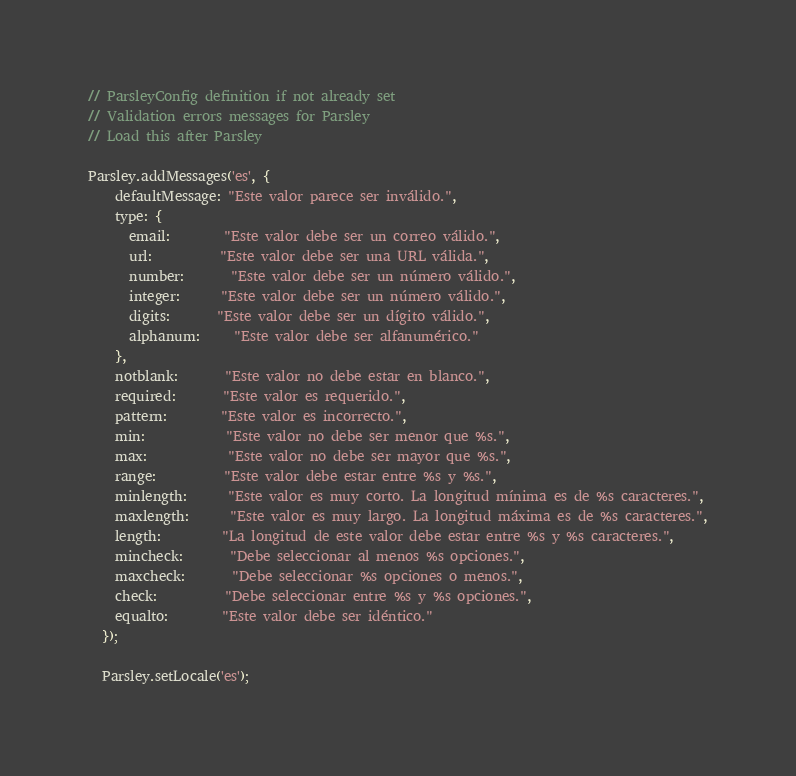Convert code to text. <code><loc_0><loc_0><loc_500><loc_500><_JavaScript_>// ParsleyConfig definition if not already set
// Validation errors messages for Parsley
// Load this after Parsley

Parsley.addMessages('es', {
    defaultMessage: "Este valor parece ser inválido.",
    type: {
      email:        "Este valor debe ser un correo válido.",
      url:          "Este valor debe ser una URL válida.",
      number:       "Este valor debe ser un número válido.",
      integer:      "Este valor debe ser un número válido.",
      digits:       "Este valor debe ser un dígito válido.",
      alphanum:     "Este valor debe ser alfanumérico."
    },
    notblank:       "Este valor no debe estar en blanco.",
    required:       "Este valor es requerido.",
    pattern:        "Este valor es incorrecto.",
    min:            "Este valor no debe ser menor que %s.",
    max:            "Este valor no debe ser mayor que %s.",
    range:          "Este valor debe estar entre %s y %s.",
    minlength:      "Este valor es muy corto. La longitud mínima es de %s caracteres.",
    maxlength:      "Este valor es muy largo. La longitud máxima es de %s caracteres.",
    length:         "La longitud de este valor debe estar entre %s y %s caracteres.",
    mincheck:       "Debe seleccionar al menos %s opciones.",
    maxcheck:       "Debe seleccionar %s opciones o menos.",
    check:          "Debe seleccionar entre %s y %s opciones.",
    equalto:        "Este valor debe ser idéntico."
  });
  
  Parsley.setLocale('es');</code> 